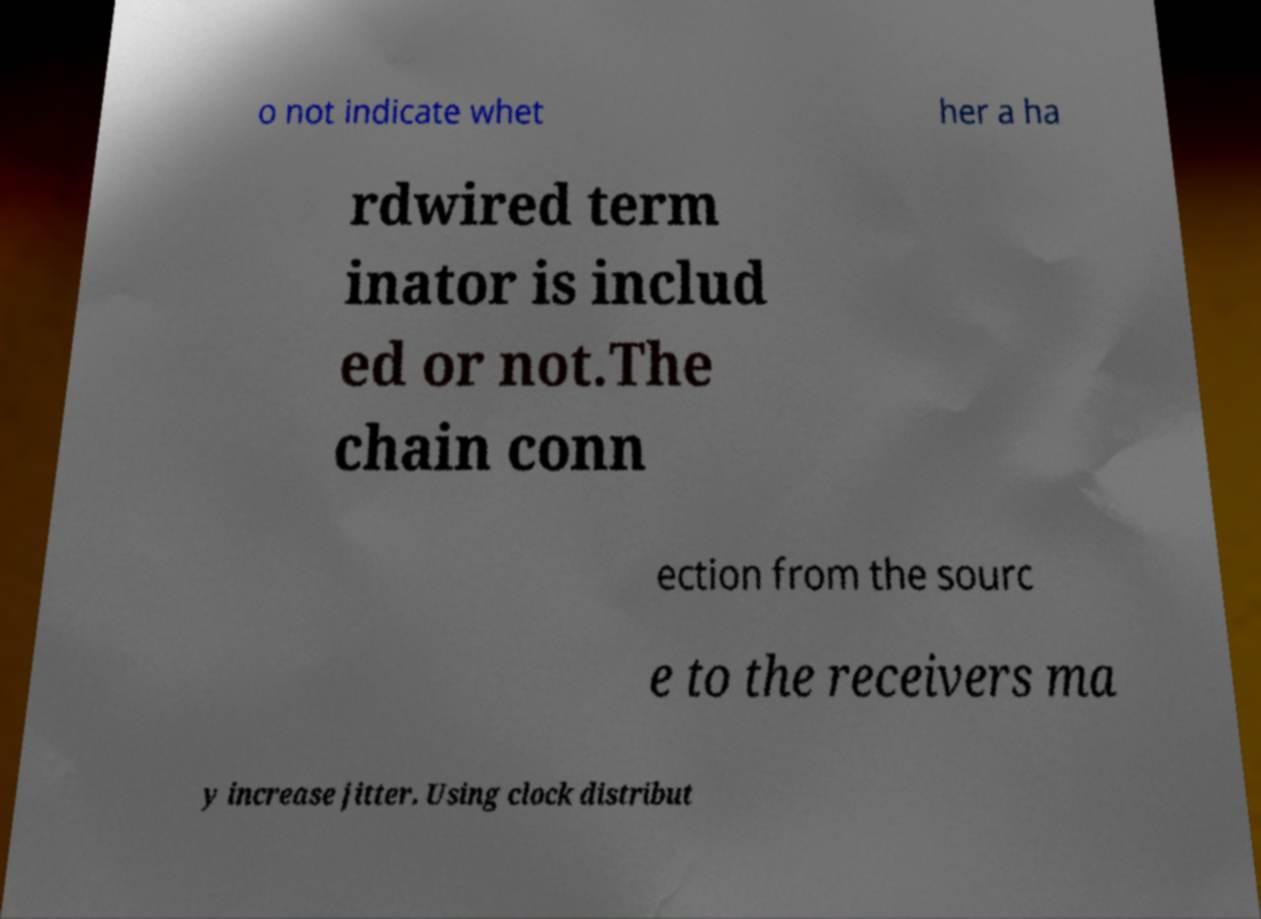Could you assist in decoding the text presented in this image and type it out clearly? o not indicate whet her a ha rdwired term inator is includ ed or not.The chain conn ection from the sourc e to the receivers ma y increase jitter. Using clock distribut 